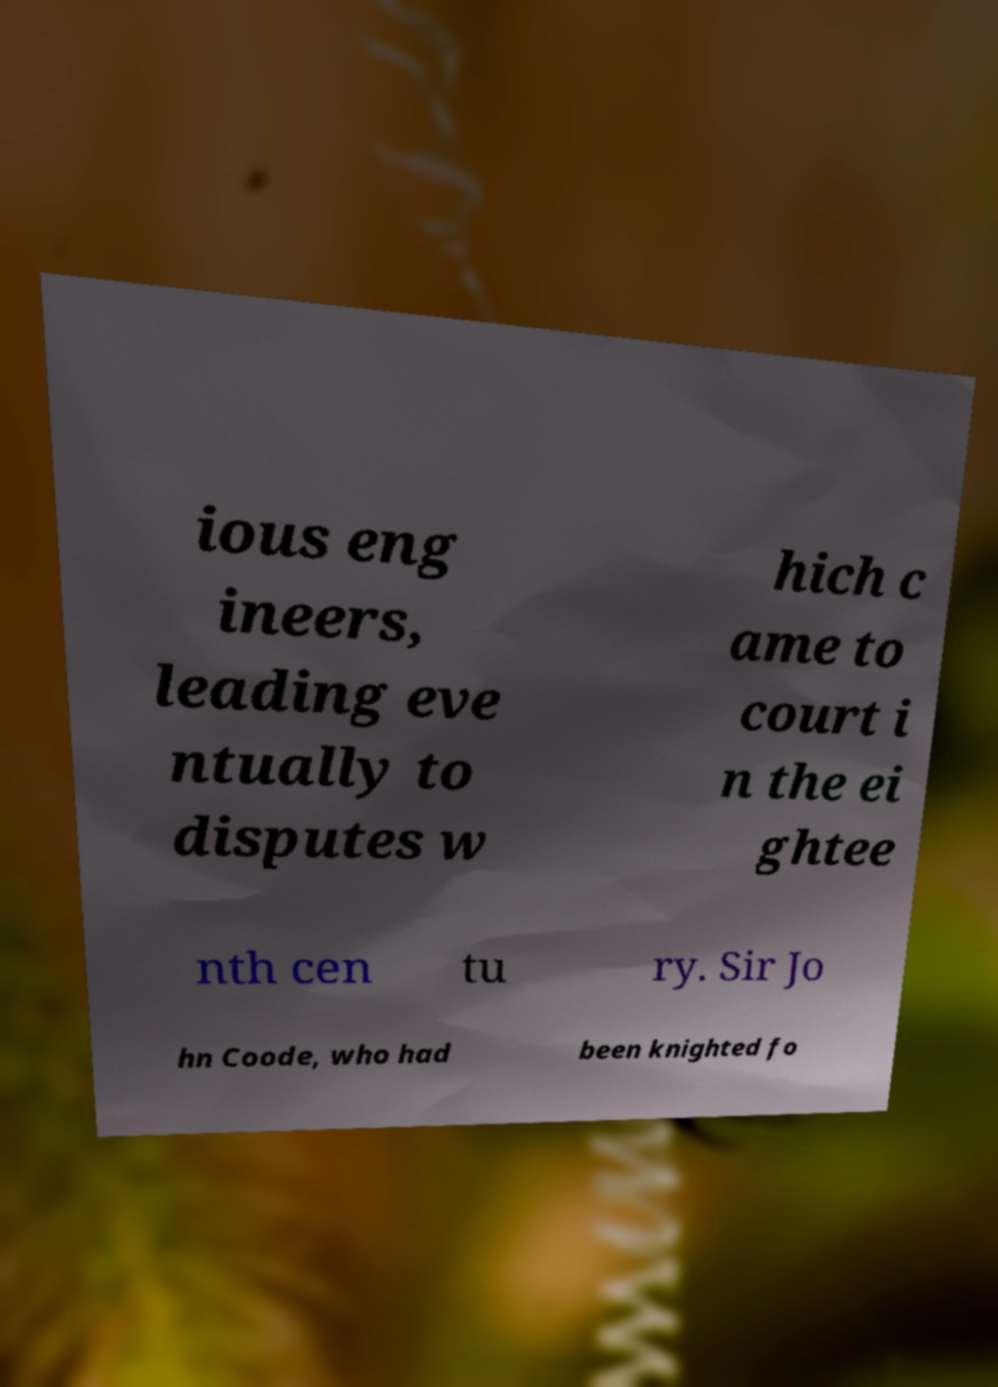Could you assist in decoding the text presented in this image and type it out clearly? ious eng ineers, leading eve ntually to disputes w hich c ame to court i n the ei ghtee nth cen tu ry. Sir Jo hn Coode, who had been knighted fo 